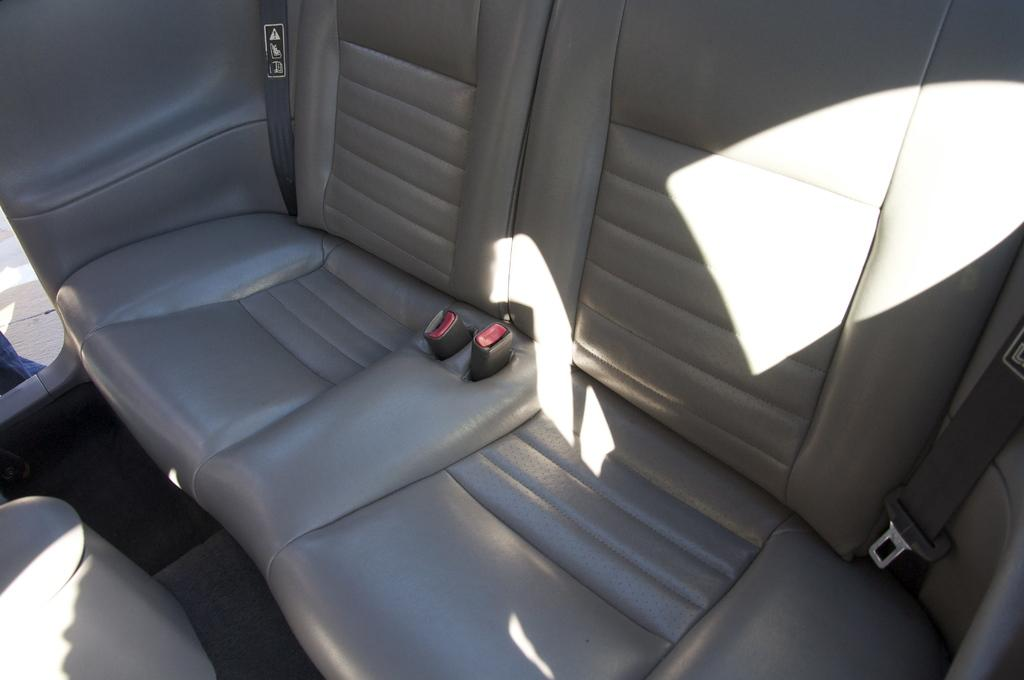What is the main subject of the image? The main subject of the image is a zoomed-in view of car seats. Can you describe the car seats in the image? Unfortunately, the image only provides a zoomed-in view of the car seats, so it's difficult to describe them in detail. What type of feast is being prepared on the car seats in the image? There is no feast or any food preparation visible in the image; it only shows a zoomed-in view of car seats. 